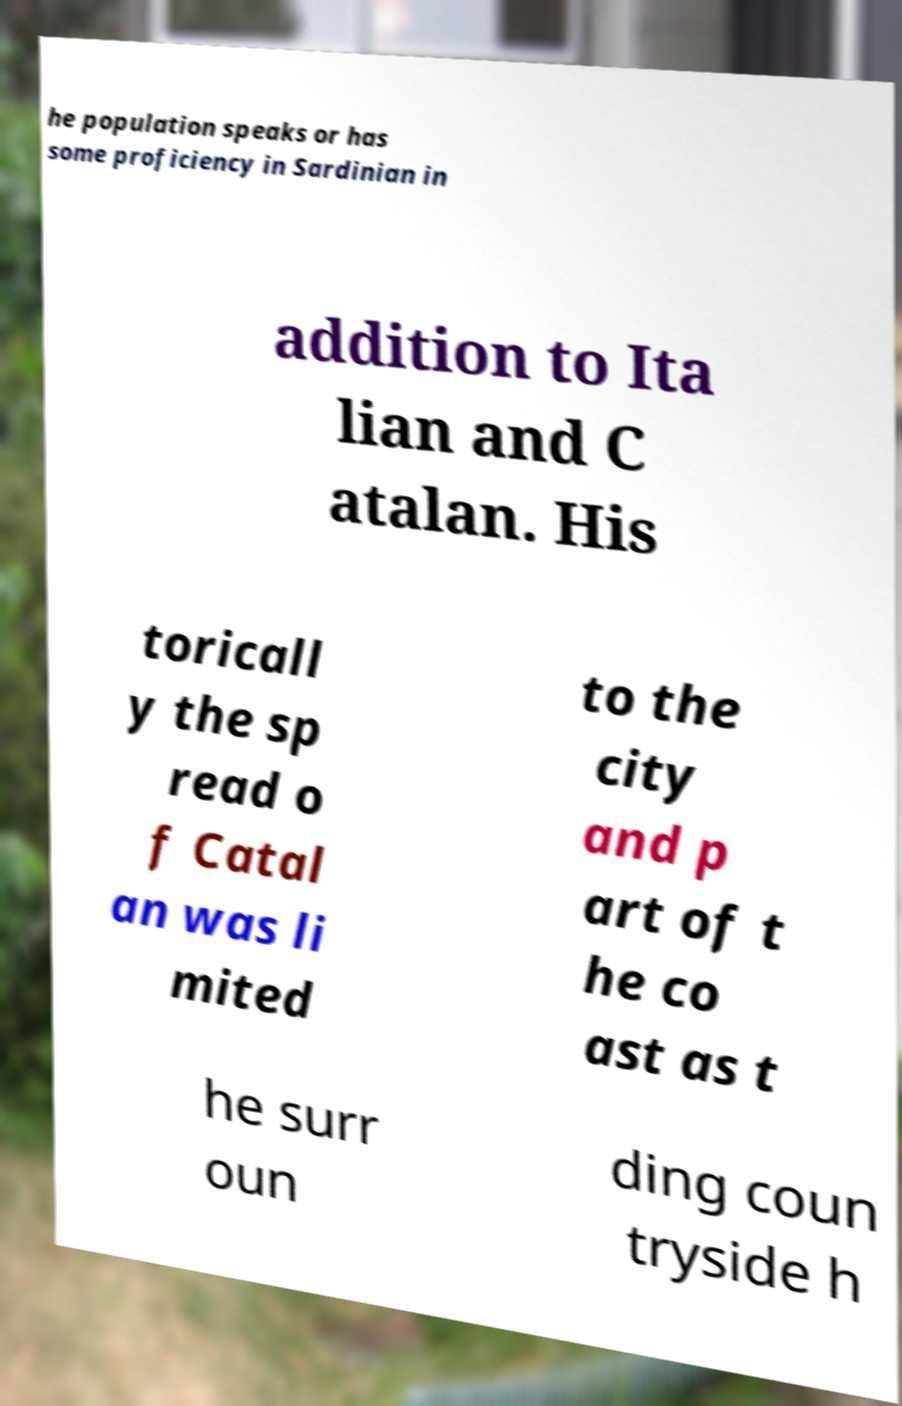For documentation purposes, I need the text within this image transcribed. Could you provide that? he population speaks or has some proficiency in Sardinian in addition to Ita lian and C atalan. His toricall y the sp read o f Catal an was li mited to the city and p art of t he co ast as t he surr oun ding coun tryside h 